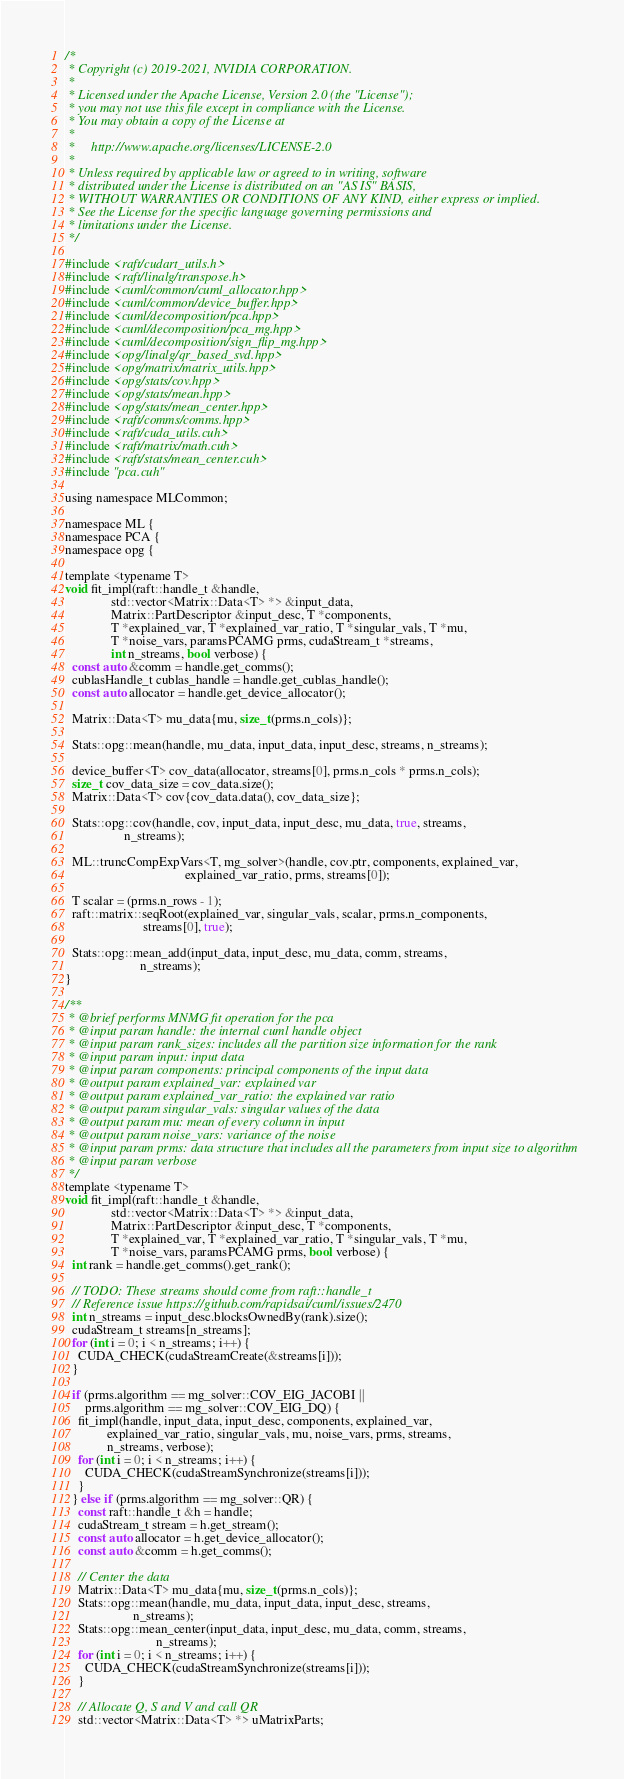<code> <loc_0><loc_0><loc_500><loc_500><_Cuda_>/*
 * Copyright (c) 2019-2021, NVIDIA CORPORATION.
 *
 * Licensed under the Apache License, Version 2.0 (the "License");
 * you may not use this file except in compliance with the License.
 * You may obtain a copy of the License at
 *
 *     http://www.apache.org/licenses/LICENSE-2.0
 *
 * Unless required by applicable law or agreed to in writing, software
 * distributed under the License is distributed on an "AS IS" BASIS,
 * WITHOUT WARRANTIES OR CONDITIONS OF ANY KIND, either express or implied.
 * See the License for the specific language governing permissions and
 * limitations under the License.
 */

#include <raft/cudart_utils.h>
#include <raft/linalg/transpose.h>
#include <cuml/common/cuml_allocator.hpp>
#include <cuml/common/device_buffer.hpp>
#include <cuml/decomposition/pca.hpp>
#include <cuml/decomposition/pca_mg.hpp>
#include <cuml/decomposition/sign_flip_mg.hpp>
#include <opg/linalg/qr_based_svd.hpp>
#include <opg/matrix/matrix_utils.hpp>
#include <opg/stats/cov.hpp>
#include <opg/stats/mean.hpp>
#include <opg/stats/mean_center.hpp>
#include <raft/comms/comms.hpp>
#include <raft/cuda_utils.cuh>
#include <raft/matrix/math.cuh>
#include <raft/stats/mean_center.cuh>
#include "pca.cuh"

using namespace MLCommon;

namespace ML {
namespace PCA {
namespace opg {

template <typename T>
void fit_impl(raft::handle_t &handle,
              std::vector<Matrix::Data<T> *> &input_data,
              Matrix::PartDescriptor &input_desc, T *components,
              T *explained_var, T *explained_var_ratio, T *singular_vals, T *mu,
              T *noise_vars, paramsPCAMG prms, cudaStream_t *streams,
              int n_streams, bool verbose) {
  const auto &comm = handle.get_comms();
  cublasHandle_t cublas_handle = handle.get_cublas_handle();
  const auto allocator = handle.get_device_allocator();

  Matrix::Data<T> mu_data{mu, size_t(prms.n_cols)};

  Stats::opg::mean(handle, mu_data, input_data, input_desc, streams, n_streams);

  device_buffer<T> cov_data(allocator, streams[0], prms.n_cols * prms.n_cols);
  size_t cov_data_size = cov_data.size();
  Matrix::Data<T> cov{cov_data.data(), cov_data_size};

  Stats::opg::cov(handle, cov, input_data, input_desc, mu_data, true, streams,
                  n_streams);

  ML::truncCompExpVars<T, mg_solver>(handle, cov.ptr, components, explained_var,
                                     explained_var_ratio, prms, streams[0]);

  T scalar = (prms.n_rows - 1);
  raft::matrix::seqRoot(explained_var, singular_vals, scalar, prms.n_components,
                        streams[0], true);

  Stats::opg::mean_add(input_data, input_desc, mu_data, comm, streams,
                       n_streams);
}

/**
 * @brief performs MNMG fit operation for the pca
 * @input param handle: the internal cuml handle object
 * @input param rank_sizes: includes all the partition size information for the rank
 * @input param input: input data
 * @input param components: principal components of the input data
 * @output param explained_var: explained var
 * @output param explained_var_ratio: the explained var ratio
 * @output param singular_vals: singular values of the data
 * @output param mu: mean of every column in input
 * @output param noise_vars: variance of the noise
 * @input param prms: data structure that includes all the parameters from input size to algorithm
 * @input param verbose
 */
template <typename T>
void fit_impl(raft::handle_t &handle,
              std::vector<Matrix::Data<T> *> &input_data,
              Matrix::PartDescriptor &input_desc, T *components,
              T *explained_var, T *explained_var_ratio, T *singular_vals, T *mu,
              T *noise_vars, paramsPCAMG prms, bool verbose) {
  int rank = handle.get_comms().get_rank();

  // TODO: These streams should come from raft::handle_t
  // Reference issue https://github.com/rapidsai/cuml/issues/2470
  int n_streams = input_desc.blocksOwnedBy(rank).size();
  cudaStream_t streams[n_streams];
  for (int i = 0; i < n_streams; i++) {
    CUDA_CHECK(cudaStreamCreate(&streams[i]));
  }

  if (prms.algorithm == mg_solver::COV_EIG_JACOBI ||
      prms.algorithm == mg_solver::COV_EIG_DQ) {
    fit_impl(handle, input_data, input_desc, components, explained_var,
             explained_var_ratio, singular_vals, mu, noise_vars, prms, streams,
             n_streams, verbose);
    for (int i = 0; i < n_streams; i++) {
      CUDA_CHECK(cudaStreamSynchronize(streams[i]));
    }
  } else if (prms.algorithm == mg_solver::QR) {
    const raft::handle_t &h = handle;
    cudaStream_t stream = h.get_stream();
    const auto allocator = h.get_device_allocator();
    const auto &comm = h.get_comms();

    // Center the data
    Matrix::Data<T> mu_data{mu, size_t(prms.n_cols)};
    Stats::opg::mean(handle, mu_data, input_data, input_desc, streams,
                     n_streams);
    Stats::opg::mean_center(input_data, input_desc, mu_data, comm, streams,
                            n_streams);
    for (int i = 0; i < n_streams; i++) {
      CUDA_CHECK(cudaStreamSynchronize(streams[i]));
    }

    // Allocate Q, S and V and call QR
    std::vector<Matrix::Data<T> *> uMatrixParts;</code> 